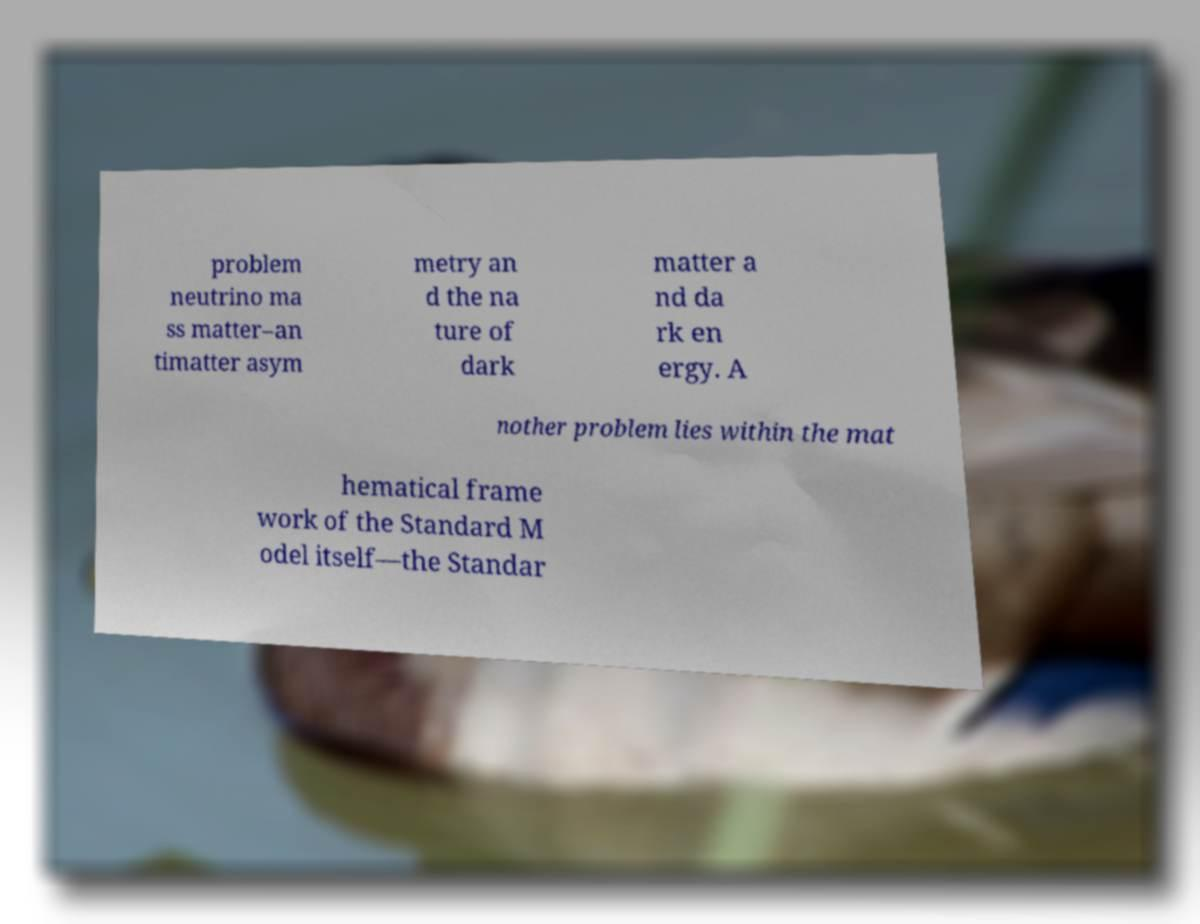For documentation purposes, I need the text within this image transcribed. Could you provide that? problem neutrino ma ss matter–an timatter asym metry an d the na ture of dark matter a nd da rk en ergy. A nother problem lies within the mat hematical frame work of the Standard M odel itself—the Standar 